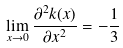<formula> <loc_0><loc_0><loc_500><loc_500>\lim _ { x \to 0 } \frac { \partial ^ { 2 } k ( x ) } { \partial x ^ { 2 } } = - \frac { 1 } { 3 }</formula> 